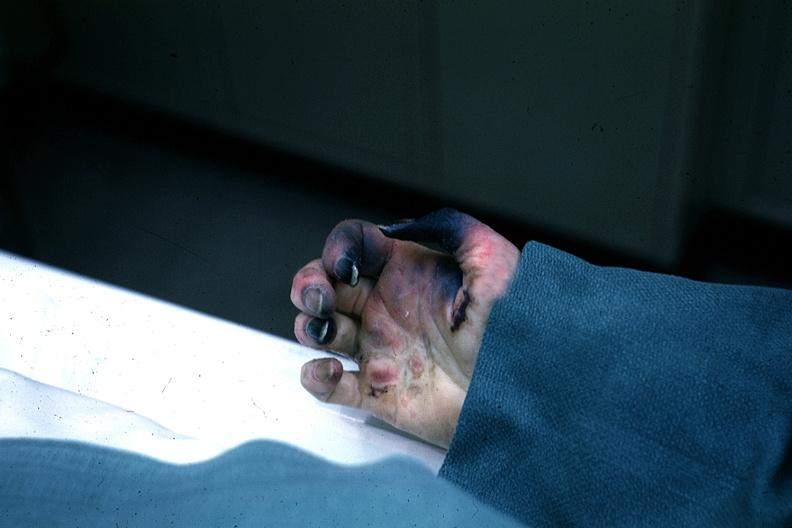does this section show excellent gangrenous necrosis of fingers said to be due to embolism?
Answer the question using a single word or phrase. No 